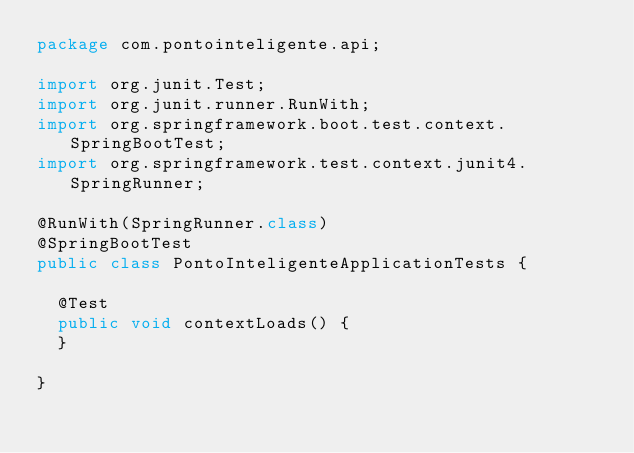<code> <loc_0><loc_0><loc_500><loc_500><_Java_>package com.pontointeligente.api;

import org.junit.Test;
import org.junit.runner.RunWith;
import org.springframework.boot.test.context.SpringBootTest;
import org.springframework.test.context.junit4.SpringRunner;

@RunWith(SpringRunner.class)
@SpringBootTest
public class PontoInteligenteApplicationTests {

	@Test
	public void contextLoads() {
	}

}
</code> 